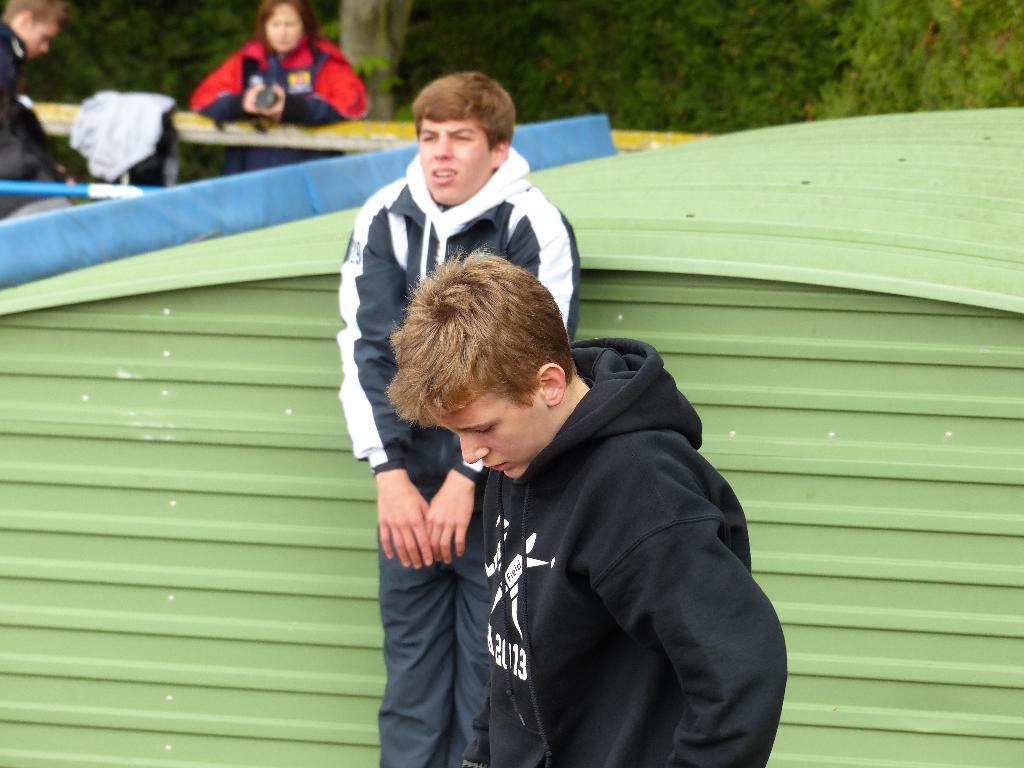In one or two sentences, can you explain what this image depicts? In this image we can see four people, among them two are standing, behind them, we can see an object which looks like a shed and other two are sitting, in front of them, we can see a table with some clothes and in the background we can see some trees. 